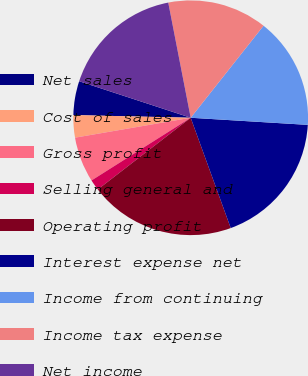Convert chart to OTSL. <chart><loc_0><loc_0><loc_500><loc_500><pie_chart><fcel>Net sales<fcel>Cost of sales<fcel>Gross profit<fcel>Selling general and<fcel>Operating profit<fcel>Interest expense net<fcel>Income from continuing<fcel>Income tax expense<fcel>Net income<nl><fcel>4.67%<fcel>3.08%<fcel>6.26%<fcel>1.49%<fcel>20.08%<fcel>18.49%<fcel>15.31%<fcel>13.72%<fcel>16.9%<nl></chart> 